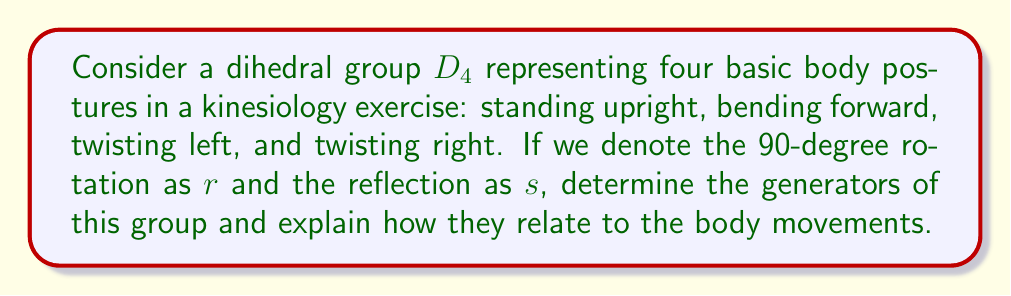Give your solution to this math problem. To solve this problem, let's follow these steps:

1) First, recall that a dihedral group $D_n$ is generally generated by two elements: a rotation $r$ of order $n$, and a reflection $s$ of order 2.

2) In this case, we have $D_4$, which represents four body postures. The elements of $D_4$ are:
   $\{e, r, r^2, r^3, s, sr, sr^2, sr^3\}$

   Where:
   - $e$ is the identity (standing upright)
   - $r$ is a 90-degree rotation (could represent twisting left)
   - $r^2$ is a 180-degree rotation (bending forward)
   - $r^3$ is a 270-degree rotation (could represent twisting right)
   - $s$ and $sr$, $sr^2$, $sr^3$ are reflections

3) The generators of $D_4$ are $r$ and $s$. We can verify this:
   - $r^4 = e$ (rotating 360 degrees brings us back to the starting position)
   - $s^2 = e$ (reflecting twice brings us back to the starting position)
   - $srs = r^{-1}$ (this is a defining relation for dihedral groups)

4) In terms of body movements:
   - $r$ could represent a 90-degree twist to the left
   - $s$ could represent bending forward and then standing up straight again

5) All other elements of the group can be generated by combinations of $r$ and $s$:
   - $r^2$ (bending forward) = $r \cdot r$ (twist left twice)
   - $r^3$ (twisting right) = $r \cdot r \cdot r$ (twist left three times)
   - $sr$ (reflection after rotation) = $s \cdot r$
   - etc.

Thus, all body postures in this exercise can be achieved by combinations of the basic movements represented by $r$ and $s$.
Answer: The generators of the dihedral group $D_4$ representing the body postures are $r$ and $s$, where $r$ represents a 90-degree rotation (e.g., twisting left) and $s$ represents a reflection (e.g., bending forward and standing up). 